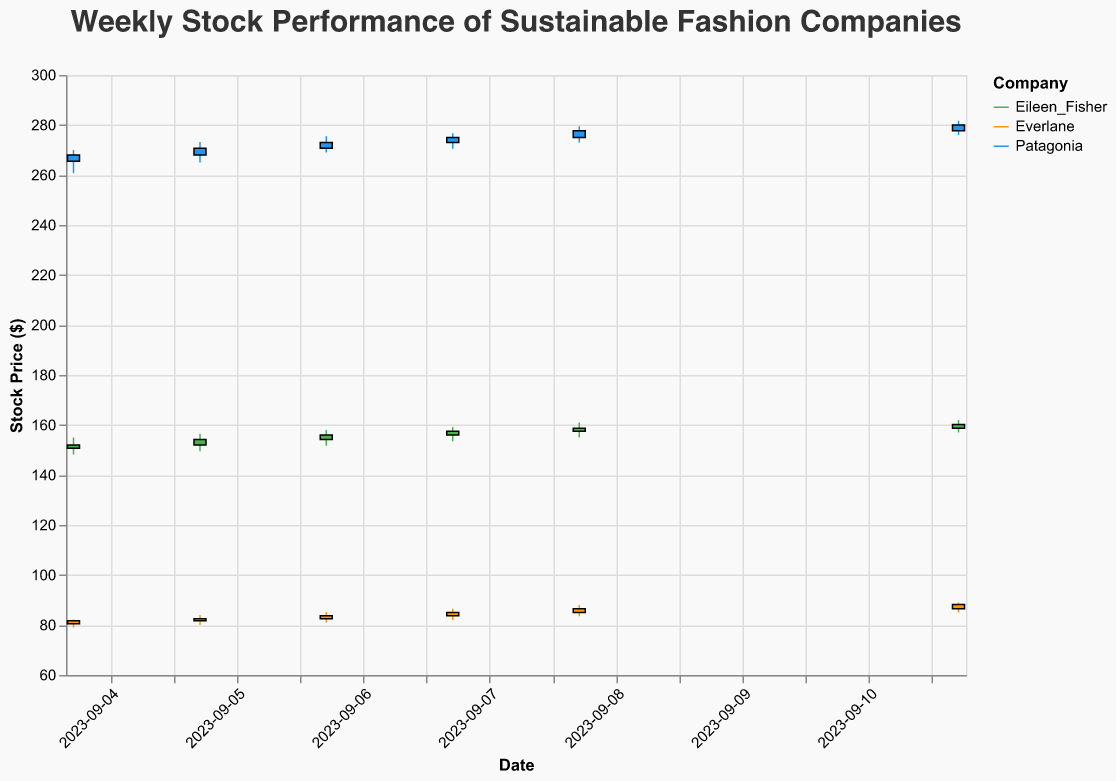What's the title of the plot? The title of the plot is displayed prominently at the top of the figure.
Answer: Weekly Stock Performance of Sustainable Fashion Companies Which companies are featured in the plot? The companies are listed as legends on the right side of the plot, each in a different color (green, orange, and blue).
Answer: Patagonia, Eileen Fisher, Everlane What is the highest stock price reached by Patagonia during the week? For each date, look at the highest point of the candlestick representing Patagonia. The highest point is 'High'.
Answer: 281.75 Which company had the highest closing price on September 11, 2023? Look at the 'Close' prices for all companies on September 11, 2023, and compare them.
Answer: Patagonia Did any company's stock price close lower than it opened on September 4, 2023? On September 4, 2023, compare the 'Open' and 'Close' prices for each company. If Close < Open, then it closed lower.
Answer: No What is the average closing price of Everlane for the week? Add up all the 'Close' prices for Everlane and divide by the number of days. Calculation: (81.75 + 82.50 + 83.75 + 85.00 + 86.50 + 88.25)/6.
Answer: 84.29 Which day saw the highest trading volume for Eileen Fisher? Check the 'Volume' column for Eileen Fisher for each date and identify the highest value.
Answer: 2023-09-11 Between Patagonia and Eileen Fisher, which company experienced the largest increase in closing price from September 4 to September 11, 2023? Calculate the difference for each company: Patagonia: 280.00 - 268.00 = 12.00; Eileen Fisher: 160.25 - 152.00 = 8.25. Compare the differences.
Answer: Patagonia On which date did Everlane have the smallest range between its highest and lowest prices? For each date, calculate the range (High - Low) for Everlane, and find the date with the smallest range.
Answer: 2023-09-06 